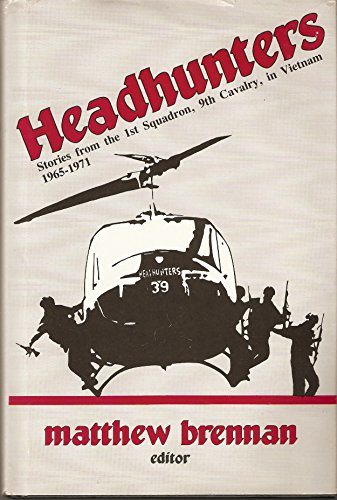Who is the author of this book? The author of the book, as prominently displayed on the cover, is Matthew Brennan, who serves as the editor of this collection of personal narratives. 